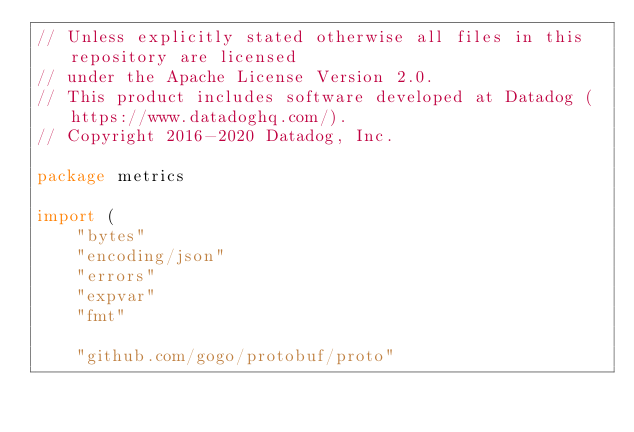Convert code to text. <code><loc_0><loc_0><loc_500><loc_500><_Go_>// Unless explicitly stated otherwise all files in this repository are licensed
// under the Apache License Version 2.0.
// This product includes software developed at Datadog (https://www.datadoghq.com/).
// Copyright 2016-2020 Datadog, Inc.

package metrics

import (
	"bytes"
	"encoding/json"
	"errors"
	"expvar"
	"fmt"

	"github.com/gogo/protobuf/proto"</code> 